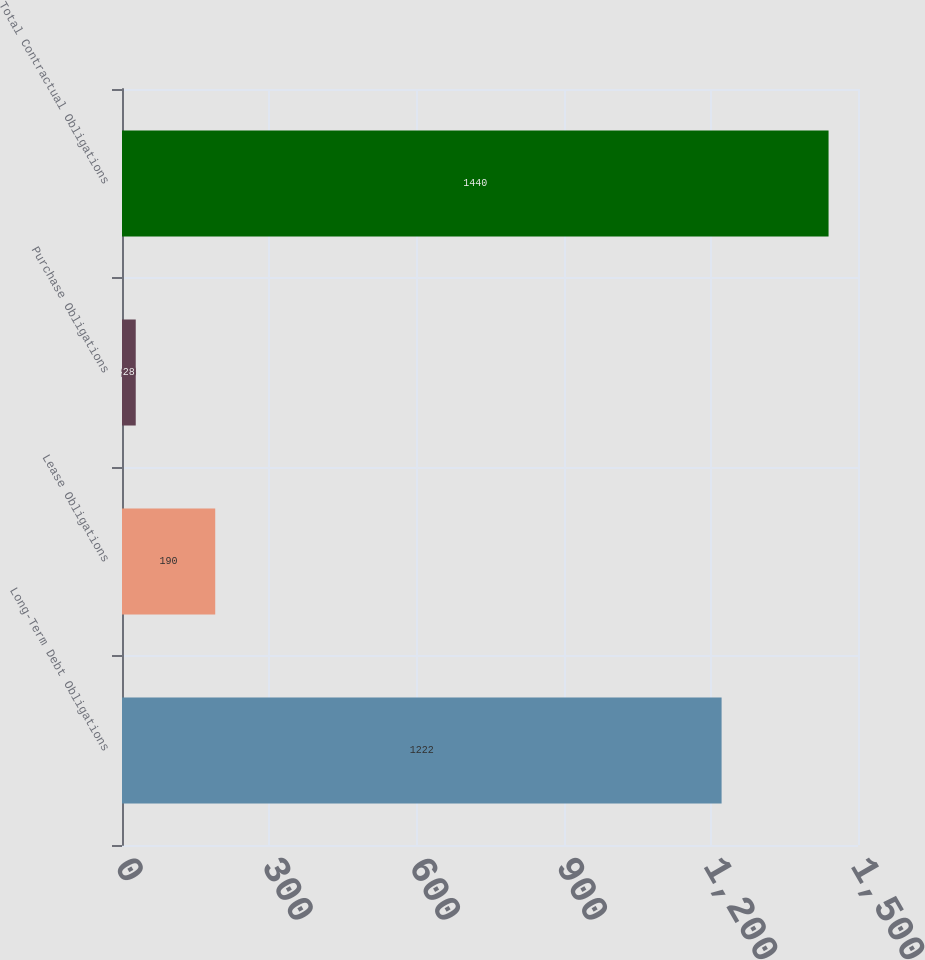Convert chart. <chart><loc_0><loc_0><loc_500><loc_500><bar_chart><fcel>Long-Term Debt Obligations<fcel>Lease Obligations<fcel>Purchase Obligations<fcel>Total Contractual Obligations<nl><fcel>1222<fcel>190<fcel>28<fcel>1440<nl></chart> 